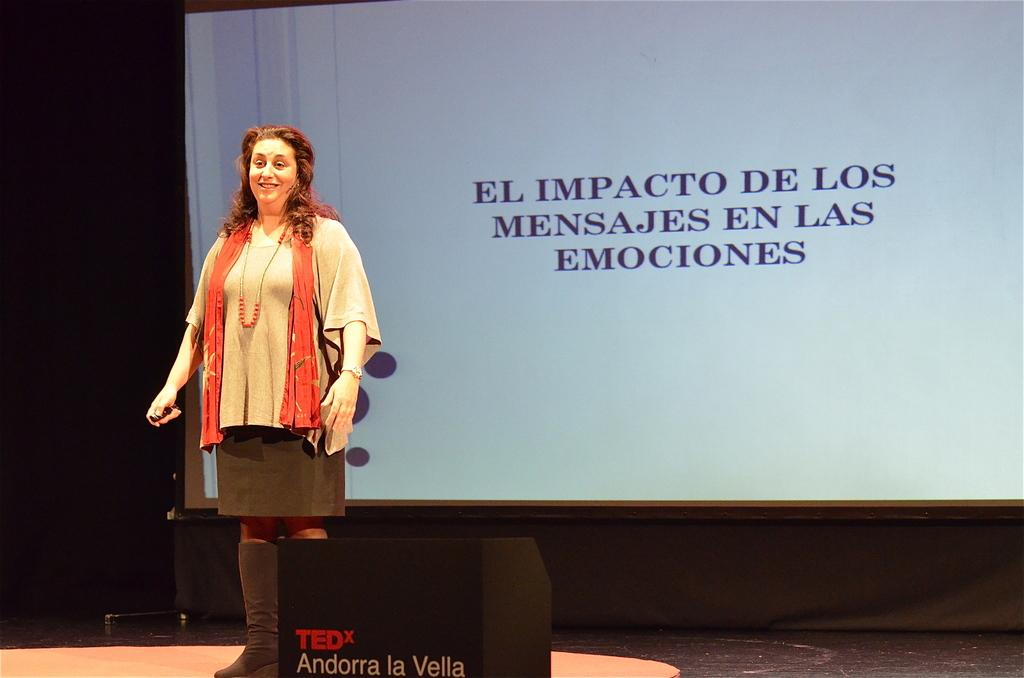What is the main subject of the image? There is a woman in the image. What is the woman doing in the image? The woman is standing on the floor and smiling. Can you describe any objects in the image? Yes, there is an object in the image. What can be seen in the background of the image? There is a screen and a cloth in the background of the image. What type of hydrant is visible in the image? There is no hydrant present in the image. How many needles are being used by the woman in the image? There is no indication of needles or any similar objects being used by the woman in the image. 